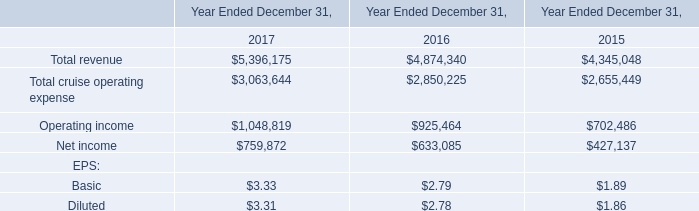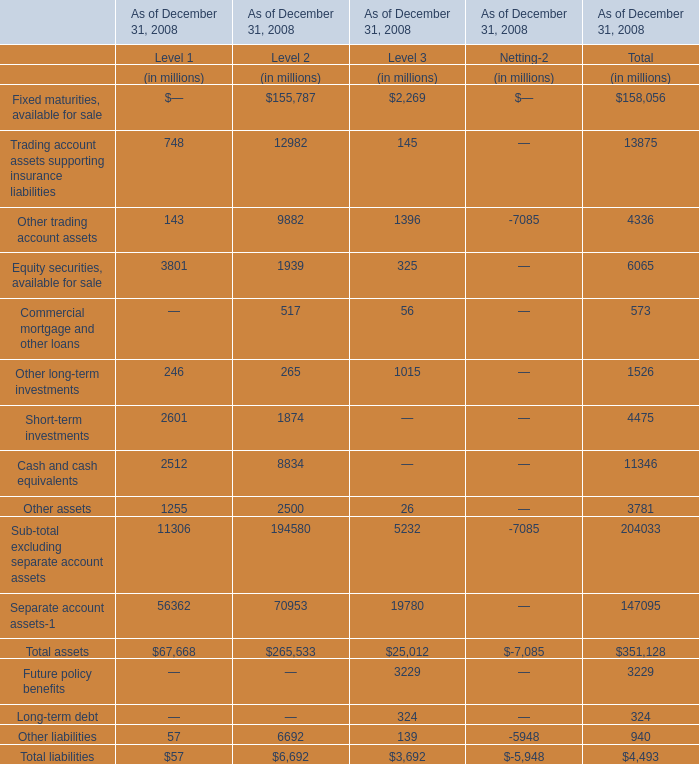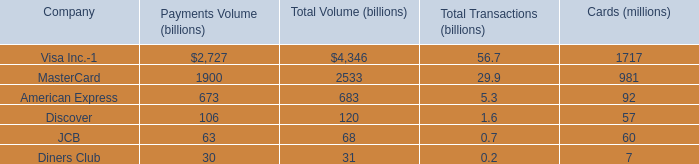Between Level 2 and Level 3,how many levels is Other assets as of December 31, 2008 greater than 1000 million? 
Answer: 1. 